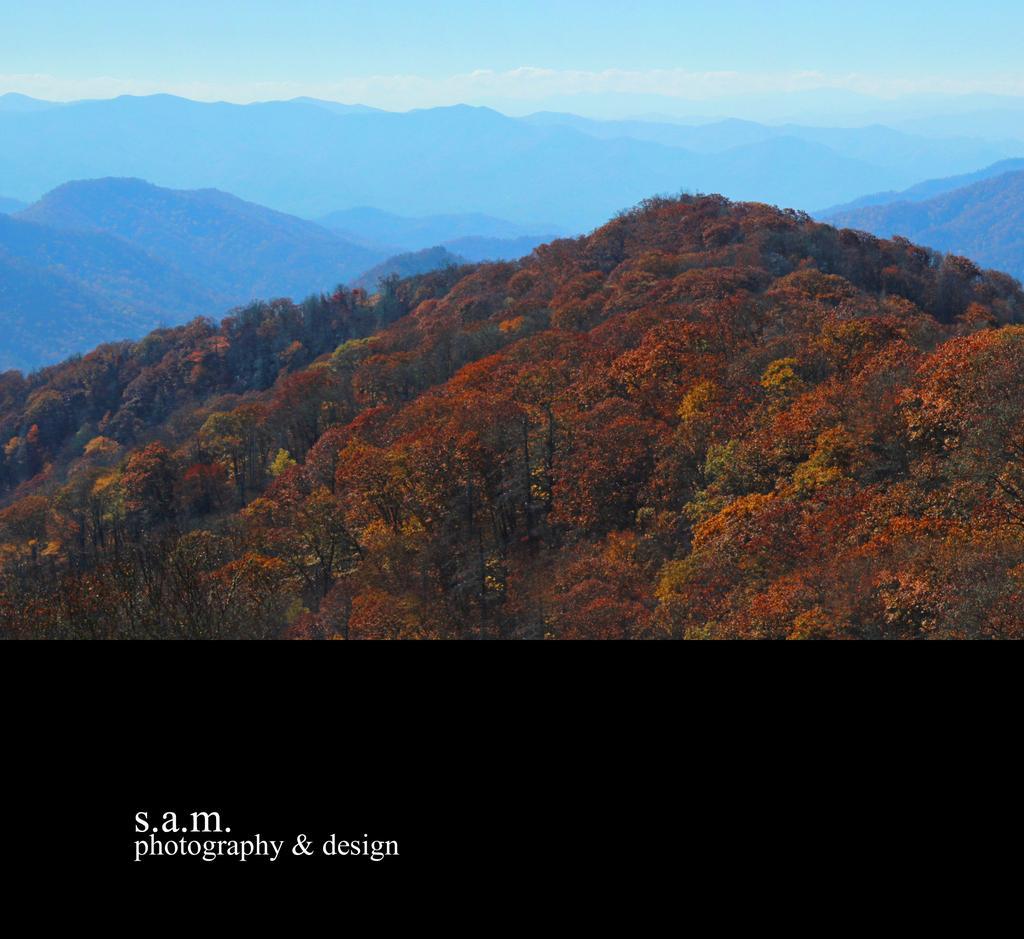Please provide a concise description of this image. In this image I can see few trees which are orange, red, yellow and green in color. In the background I can see few mountains and the sky. I can see few words written on the bottom of the image with white color. 